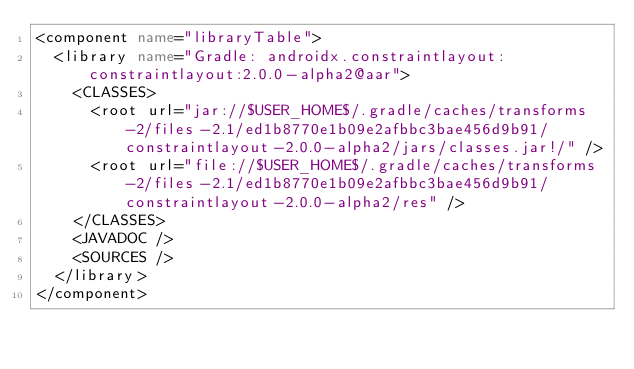Convert code to text. <code><loc_0><loc_0><loc_500><loc_500><_XML_><component name="libraryTable">
  <library name="Gradle: androidx.constraintlayout:constraintlayout:2.0.0-alpha2@aar">
    <CLASSES>
      <root url="jar://$USER_HOME$/.gradle/caches/transforms-2/files-2.1/ed1b8770e1b09e2afbbc3bae456d9b91/constraintlayout-2.0.0-alpha2/jars/classes.jar!/" />
      <root url="file://$USER_HOME$/.gradle/caches/transforms-2/files-2.1/ed1b8770e1b09e2afbbc3bae456d9b91/constraintlayout-2.0.0-alpha2/res" />
    </CLASSES>
    <JAVADOC />
    <SOURCES />
  </library>
</component></code> 